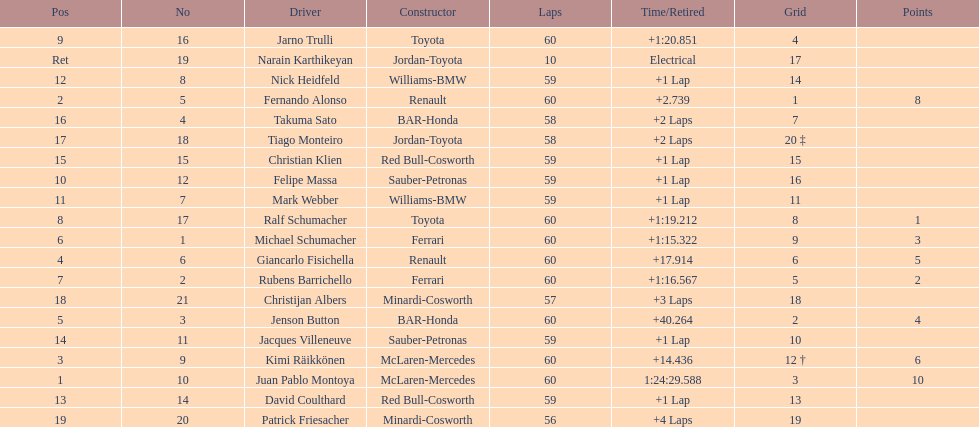After 8th position, how many points does a driver receive? 0. 